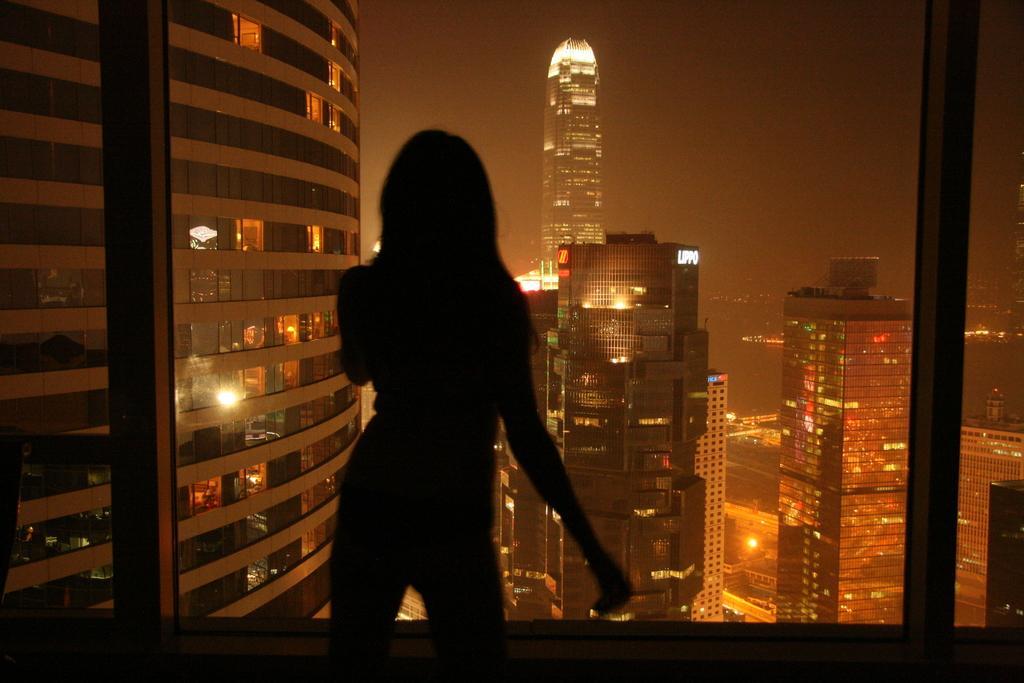How would you summarize this image in a sentence or two? In the center of the image there is a lady. In the background of the image there are buildings. At the top of the image there is sky. 